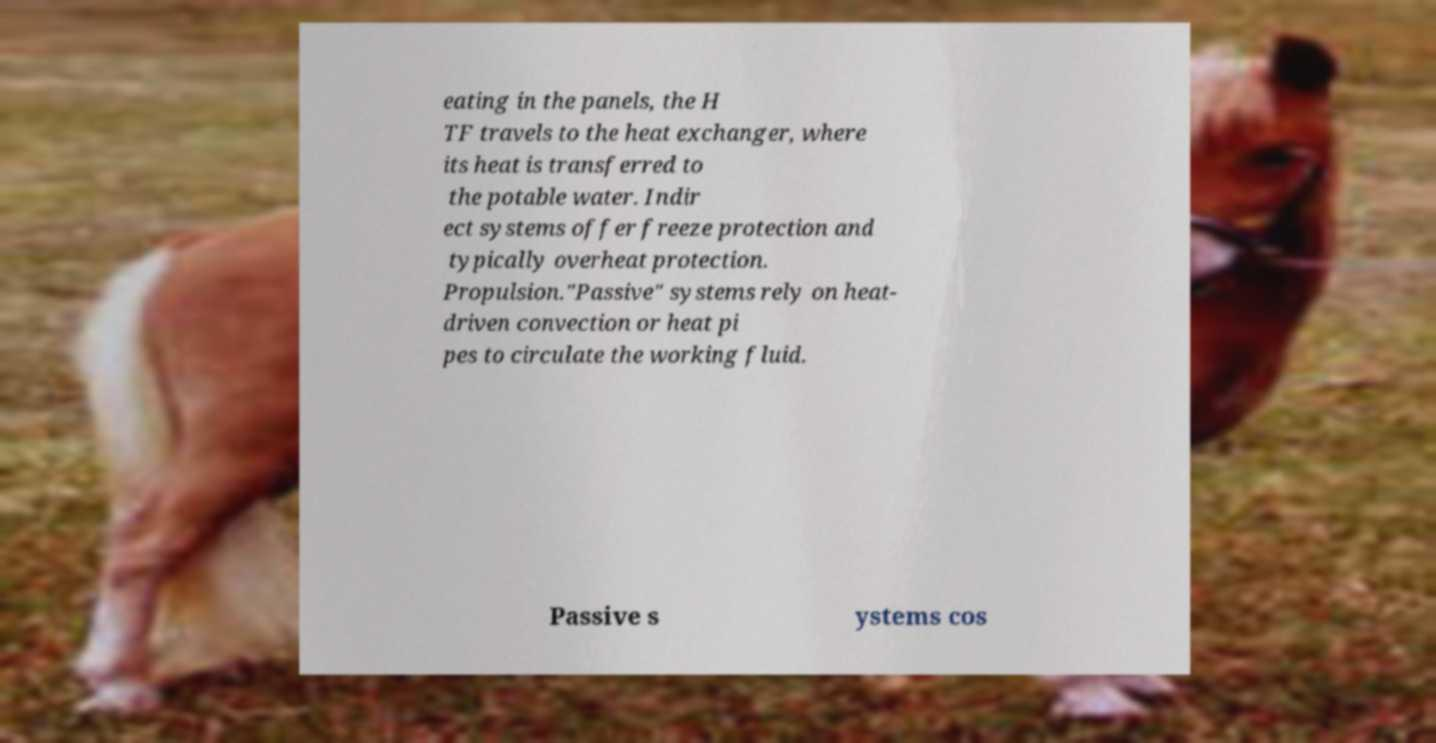Could you assist in decoding the text presented in this image and type it out clearly? eating in the panels, the H TF travels to the heat exchanger, where its heat is transferred to the potable water. Indir ect systems offer freeze protection and typically overheat protection. Propulsion."Passive" systems rely on heat- driven convection or heat pi pes to circulate the working fluid. Passive s ystems cos 